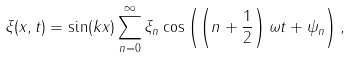<formula> <loc_0><loc_0><loc_500><loc_500>\xi ( x , t ) = \sin ( k x ) \sum _ { n = 0 } ^ { \infty } \xi _ { n } \cos \left ( \left ( n + \frac { 1 } { 2 } \right ) \omega t + \psi _ { n } \right ) ,</formula> 